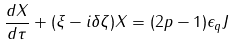<formula> <loc_0><loc_0><loc_500><loc_500>\frac { d X } { d \tau } + ( \xi - i \delta \zeta ) X = ( 2 p - 1 ) \epsilon _ { q } J</formula> 